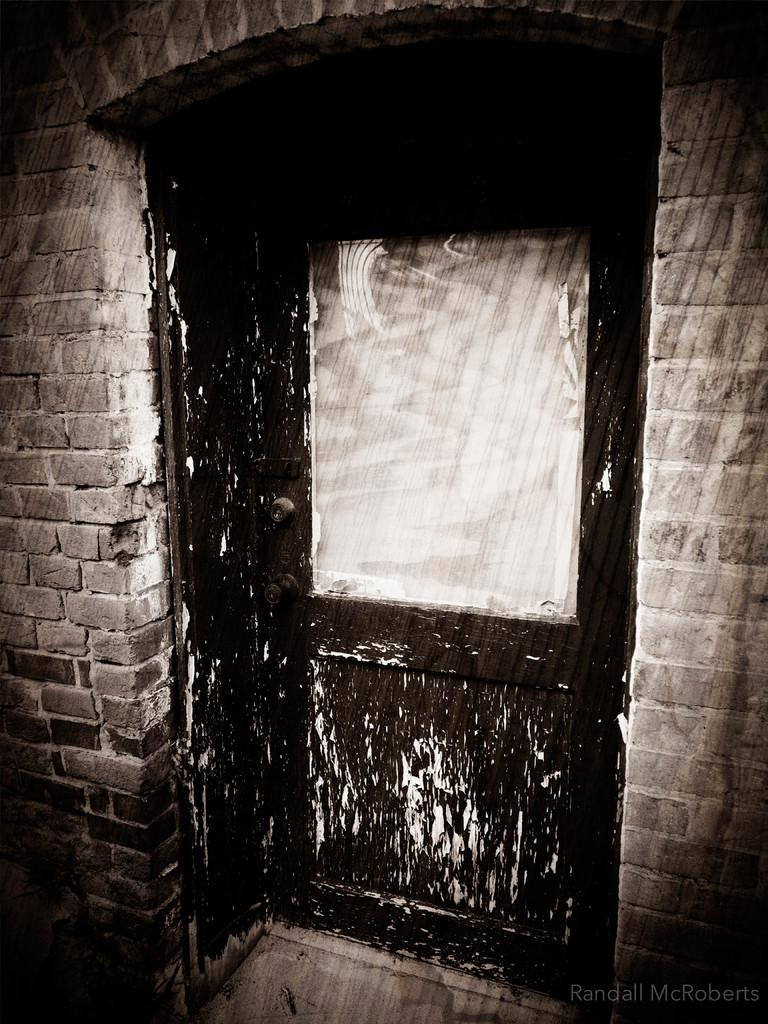What type of image is being described? The image is an edited picture. What can be seen in the background of the image? There is a building in the image. What is located in the foreground of the image? There is a door in the foreground of the image. Where is the text located in the image? The text is at the bottom right of the image. How many letters are visible on the nail in the image? There is no nail or letters present in the image. 